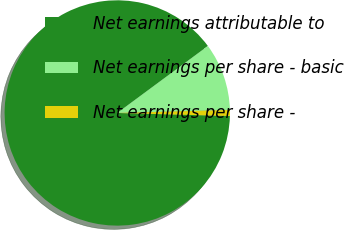Convert chart. <chart><loc_0><loc_0><loc_500><loc_500><pie_chart><fcel>Net earnings attributable to<fcel>Net earnings per share - basic<fcel>Net earnings per share -<nl><fcel>89.44%<fcel>9.71%<fcel>0.85%<nl></chart> 